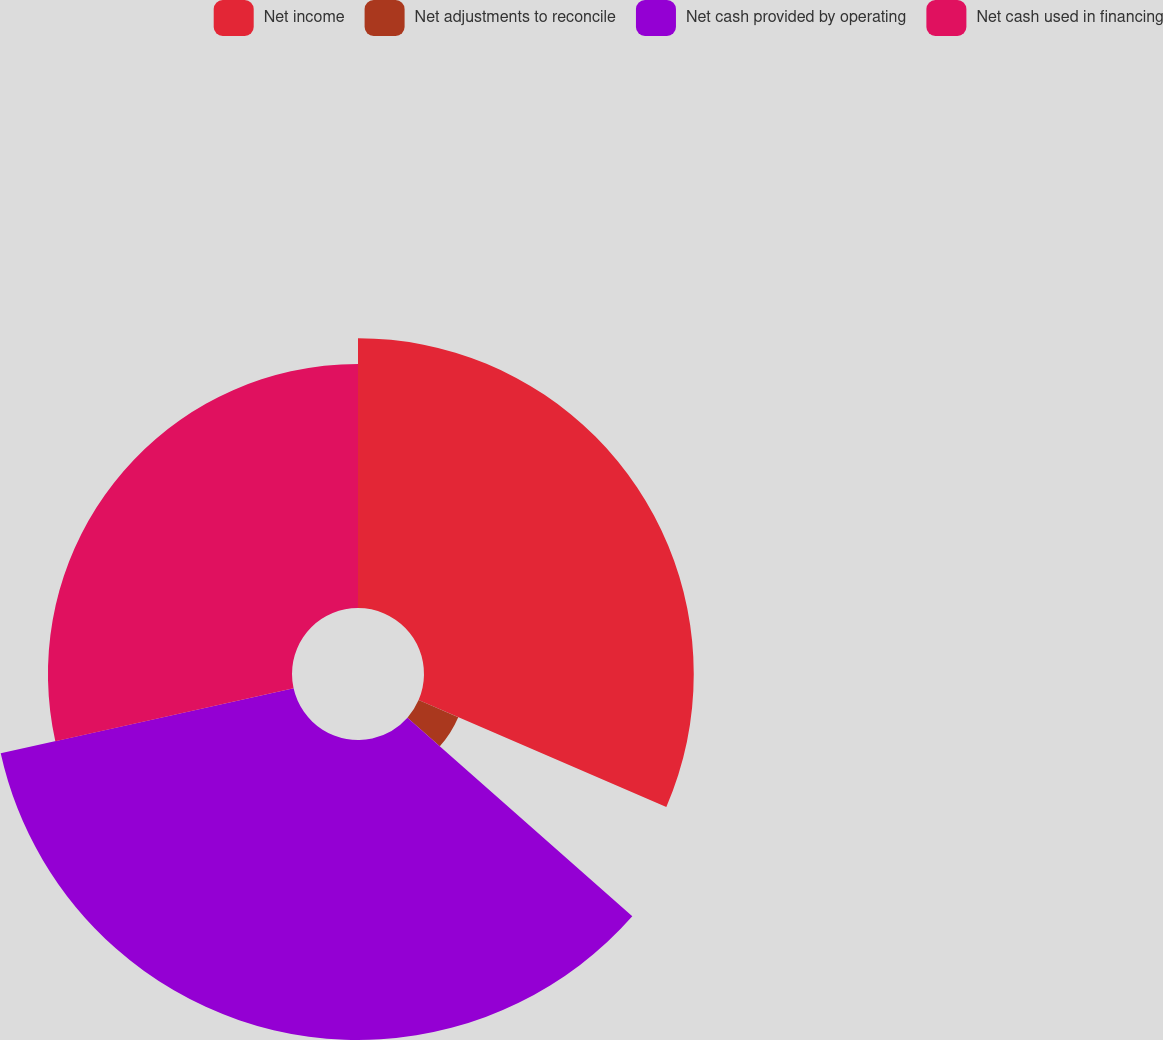<chart> <loc_0><loc_0><loc_500><loc_500><pie_chart><fcel>Net income<fcel>Net adjustments to reconcile<fcel>Net cash provided by operating<fcel>Net cash used in financing<nl><fcel>31.48%<fcel>5.04%<fcel>35.01%<fcel>28.48%<nl></chart> 